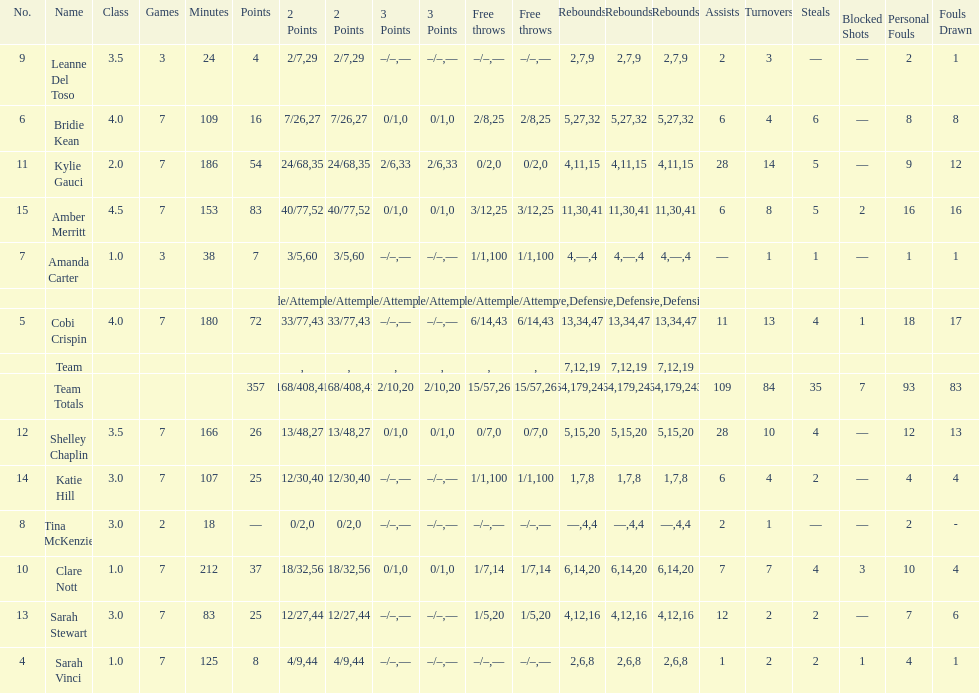Would you be able to parse every entry in this table? {'header': ['No.', 'Name', 'Class', 'Games', 'Minutes', 'Points', '2 Points', '2 Points', '3 Points', '3 Points', 'Free throws', 'Free throws', 'Rebounds', 'Rebounds', 'Rebounds', 'Assists', 'Turnovers', 'Steals', 'Blocked Shots', 'Personal Fouls', 'Fouls Drawn'], 'rows': [['9', 'Leanne Del Toso', '3.5', '3', '24', '4', '2/7', '29', '–/–', '—', '–/–', '—', '2', '7', '9', '2', '3', '—', '—', '2', '1'], ['6', 'Bridie Kean', '4.0', '7', '109', '16', '7/26', '27', '0/1', '0', '2/8', '25', '5', '27', '32', '6', '4', '6', '—', '8', '8'], ['11', 'Kylie Gauci', '2.0', '7', '186', '54', '24/68', '35', '2/6', '33', '0/2', '0', '4', '11', '15', '28', '14', '5', '—', '9', '12'], ['15', 'Amber Merritt', '4.5', '7', '153', '83', '40/77', '52', '0/1', '0', '3/12', '25', '11', '30', '41', '6', '8', '5', '2', '16', '16'], ['7', 'Amanda Carter', '1.0', '3', '38', '7', '3/5', '60', '–/–', '—', '1/1', '100', '4', '—', '4', '—', '1', '1', '—', '1', '1'], ['', '', '', '', '', '', 'Made/Attempts', '%', 'Made/Attempts', '%', 'Made/Attempts', '%', 'Offensive', 'Defensive', 'Total', '', '', '', '', '', ''], ['5', 'Cobi Crispin', '4.0', '7', '180', '72', '33/77', '43', '–/–', '—', '6/14', '43', '13', '34', '47', '11', '13', '4', '1', '18', '17'], ['', 'Team', '', '', '', '', '', '', '', '', '', '', '7', '12', '19', '', '', '', '', '', ''], ['', 'Team Totals', '', '', '', '357', '168/408', '41', '2/10', '20', '15/57', '26', '64', '179', '243', '109', '84', '35', '7', '93', '83'], ['12', 'Shelley Chaplin', '3.5', '7', '166', '26', '13/48', '27', '0/1', '0', '0/7', '0', '5', '15', '20', '28', '10', '4', '—', '12', '13'], ['14', 'Katie Hill', '3.0', '7', '107', '25', '12/30', '40', '–/–', '—', '1/1', '100', '1', '7', '8', '6', '4', '2', '—', '4', '4'], ['8', 'Tina McKenzie', '3.0', '2', '18', '—', '0/2', '0', '–/–', '—', '–/–', '—', '—', '4', '4', '2', '1', '—', '—', '2', '-'], ['10', 'Clare Nott', '1.0', '7', '212', '37', '18/32', '56', '0/1', '0', '1/7', '14', '6', '14', '20', '7', '7', '4', '3', '10', '4'], ['13', 'Sarah Stewart', '3.0', '7', '83', '25', '12/27', '44', '–/–', '—', '1/5', '20', '4', '12', '16', '12', '2', '2', '—', '7', '6'], ['4', 'Sarah Vinci', '1.0', '7', '125', '8', '4/9', '44', '–/–', '—', '–/–', '—', '2', '6', '8', '1', '2', '2', '1', '4', '1']]} Which player played in the least games? Tina McKenzie. 